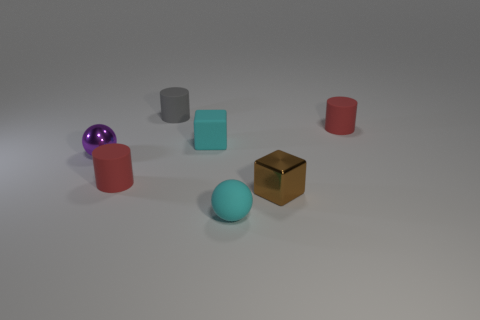Is the material of the purple object the same as the cylinder to the right of the matte block?
Provide a succinct answer. No. What is the shape of the metallic thing in front of the red rubber cylinder to the left of the small cyan rubber ball?
Offer a terse response. Cube. There is a small matte sphere; does it have the same color as the tiny cube that is on the left side of the small brown shiny object?
Your answer should be very brief. Yes. There is a small gray object; what shape is it?
Offer a very short reply. Cylinder. Are there an equal number of cyan blocks that are behind the tiny gray object and tiny brown metal cubes that are left of the tiny matte ball?
Offer a terse response. Yes. There is a thing that is behind the tiny cyan block and right of the small gray matte cylinder; what material is it made of?
Your answer should be compact. Rubber. How many other objects are the same color as the tiny metal sphere?
Your answer should be very brief. 0. Is the number of tiny red matte things to the right of the cyan sphere greater than the number of big gray balls?
Ensure brevity in your answer.  Yes. What is the color of the tiny metallic cube that is to the left of the tiny red object right of the cyan object right of the small cyan cube?
Offer a very short reply. Brown. Do the tiny cyan ball and the brown thing have the same material?
Keep it short and to the point. No. 